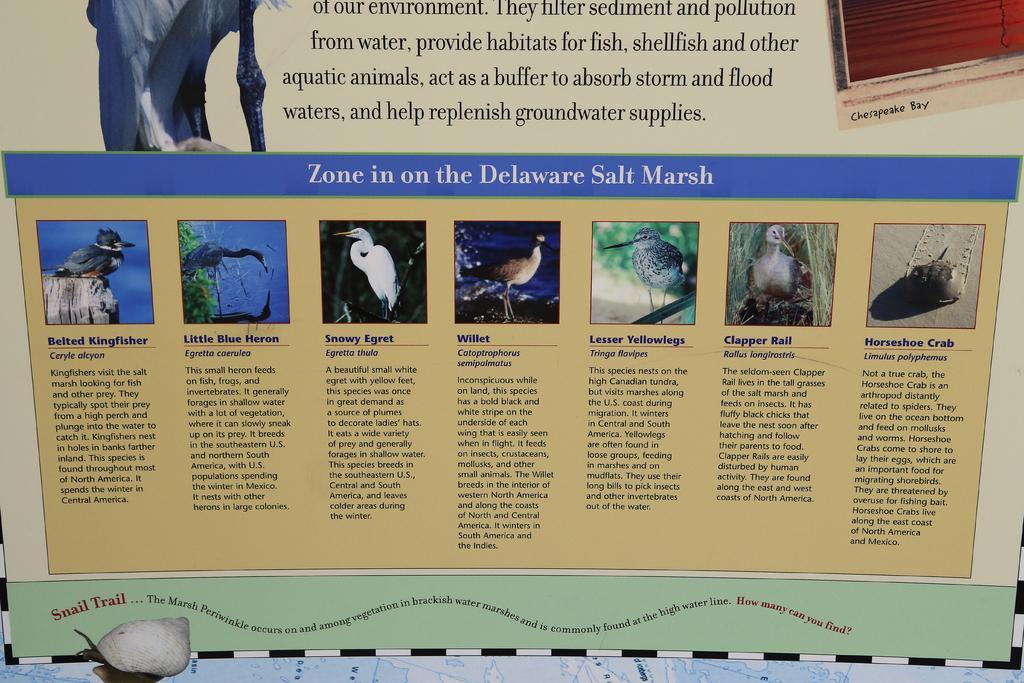How would you summarize this image in a sentence or two? In this image we can see a board. 